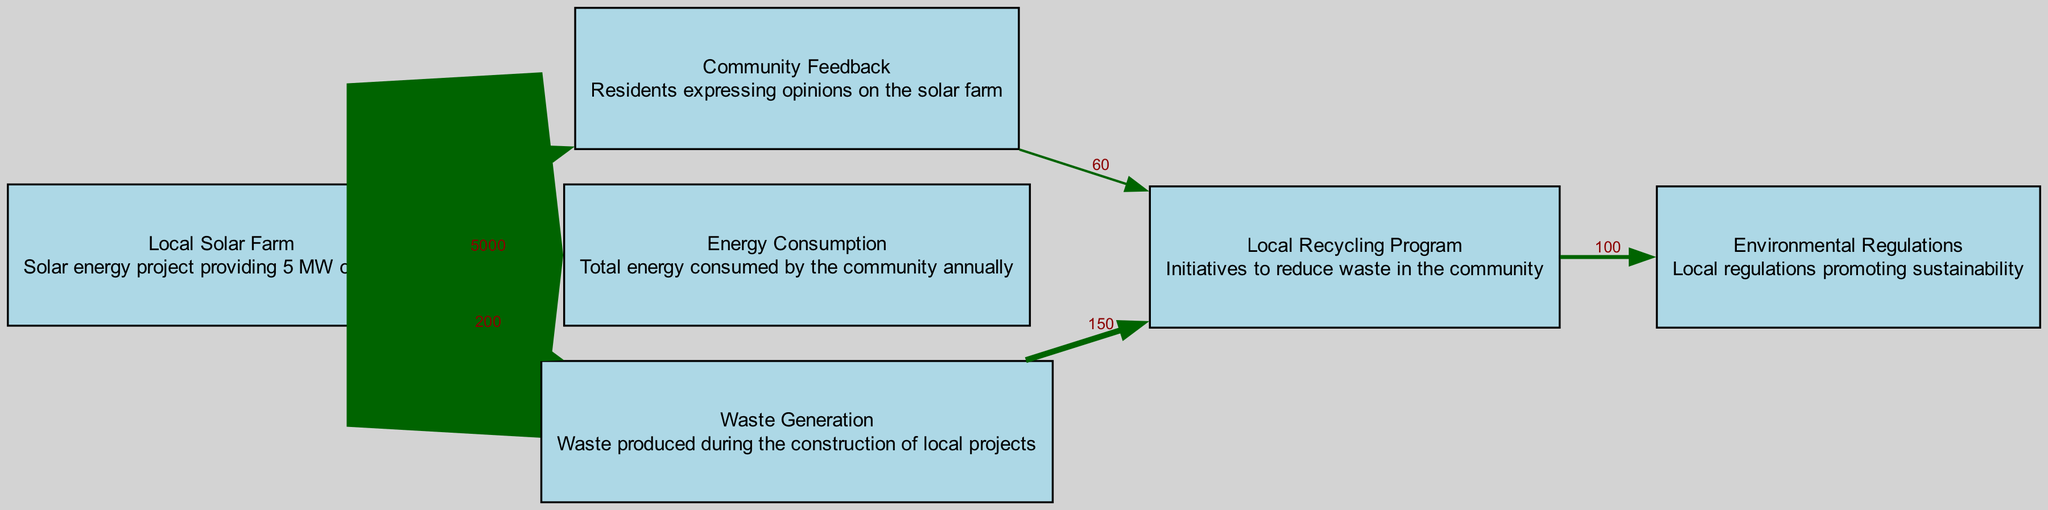What is the energy produced by the local solar farm? The local solar farm is described as providing 5 MW of energy, which is directly stated in the node description.
Answer: 5 MW How much waste is generated during the solar farm project? The waste generation from the solar farm project is indicated as 200 in the link connecting the Local Solar Farm to Waste Generation.
Answer: 200 What percentage of community feedback is directed towards the local recycling program? The link from Community Feedback to Local Recycling Program shows a value of 60, which represents the flow of feedback specifically directed towards the recycling initiative.
Answer: 60 How many nodes are connected to the Local Solar Farm? From the diagram, the Local Solar Farm connects to three other nodes: Community Feedback, Energy Consumption, and Waste Generation, totaling three connections.
Answer: 3 What is the total value of waste directed to the local recycling program? The local recycling program receives waste from two sources: 150 from Waste Generation and an additional 60 from Community Feedback. Thus, the total value is 150 + 60, which equals 210.
Answer: 210 How does the Local Recycling Program relate to Environmental Regulations? The Local Recycling Program connects to Environmental Regulations with a value of 100, indicating that it helps foster compliance with these regulations.
Answer: 100 Which node has the highest incoming value? Upon reviewing the links, the Local Solar Farm has the highest incoming directed flows: 5000 for Energy Consumption, 200 for Waste Generation, and 80 for Community Feedback, adding up to 5280.
Answer: 5000 What action does community feedback promote according to the diagram? The community feedback influences the local recycling program directly, with a flow value of 60 connecting these two nodes.
Answer: Local Recycling Program What is the total energy consumed by the community annually? The total annual energy consumption mentioned is a single value of 5000, which is indicated in the link from the Local Solar Farm to Energy Consumption.
Answer: 5000 